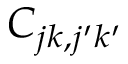<formula> <loc_0><loc_0><loc_500><loc_500>C _ { j k , j ^ { \prime } k ^ { \prime } }</formula> 